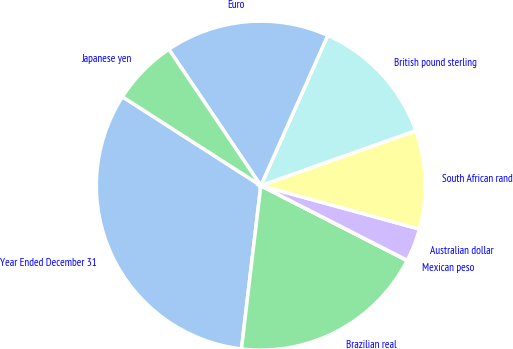<chart> <loc_0><loc_0><loc_500><loc_500><pie_chart><fcel>Year Ended December 31<fcel>Brazilian real<fcel>Mexican peso<fcel>Australian dollar<fcel>South African rand<fcel>British pound sterling<fcel>Euro<fcel>Japanese yen<nl><fcel>32.21%<fcel>19.34%<fcel>0.03%<fcel>3.25%<fcel>9.68%<fcel>12.9%<fcel>16.12%<fcel>6.47%<nl></chart> 